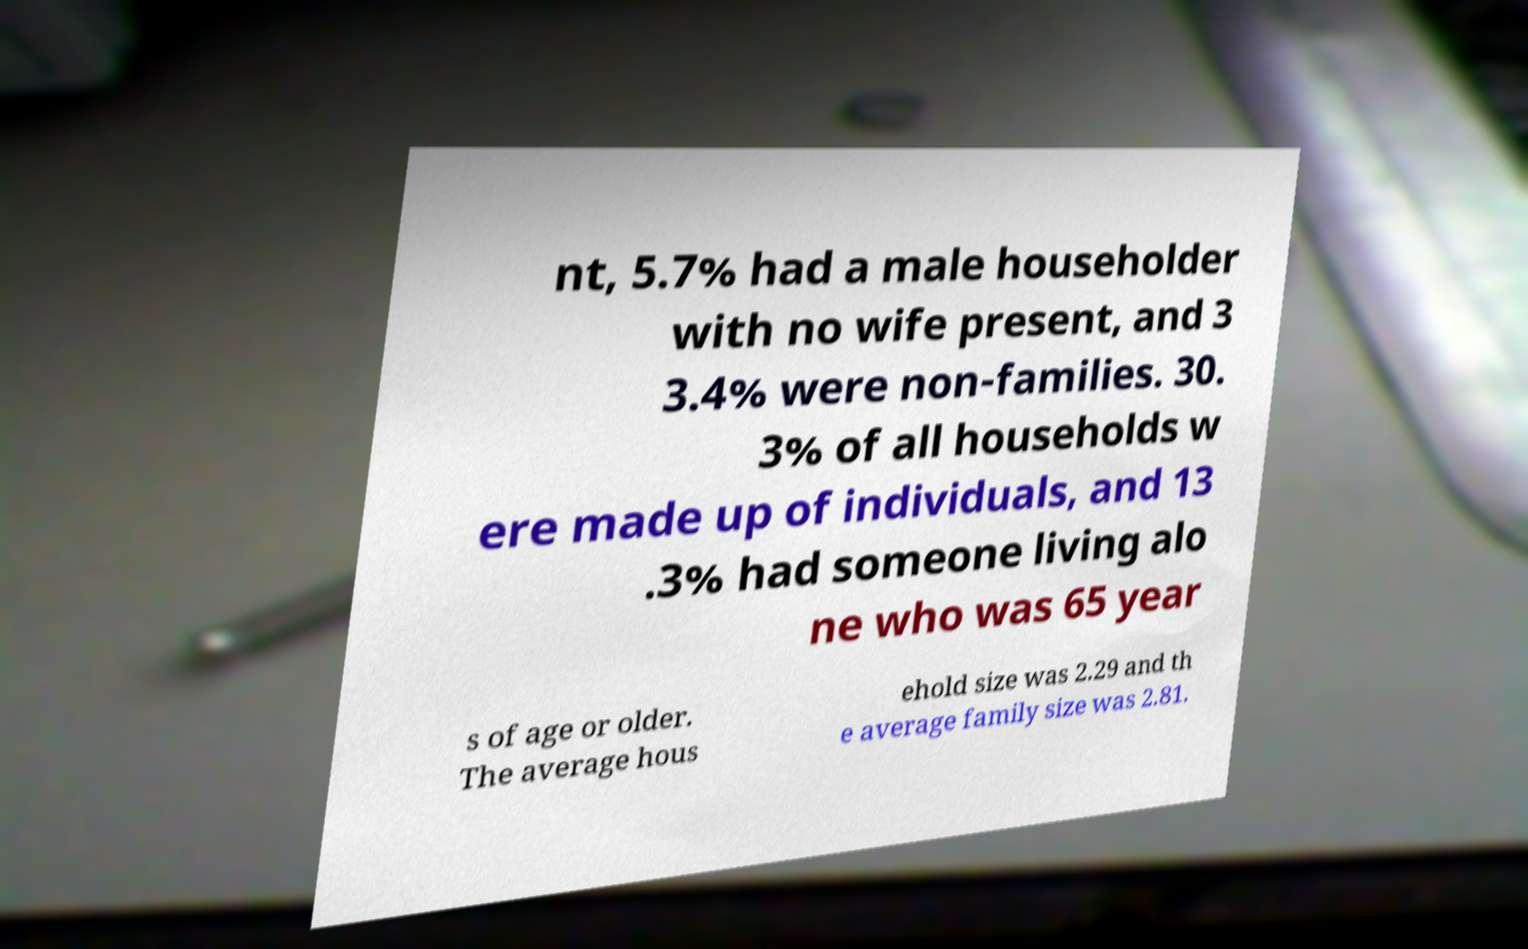Can you accurately transcribe the text from the provided image for me? nt, 5.7% had a male householder with no wife present, and 3 3.4% were non-families. 30. 3% of all households w ere made up of individuals, and 13 .3% had someone living alo ne who was 65 year s of age or older. The average hous ehold size was 2.29 and th e average family size was 2.81. 